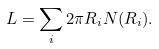Convert formula to latex. <formula><loc_0><loc_0><loc_500><loc_500>L = \sum _ { i } 2 \pi R _ { i } N ( R _ { i } ) .</formula> 